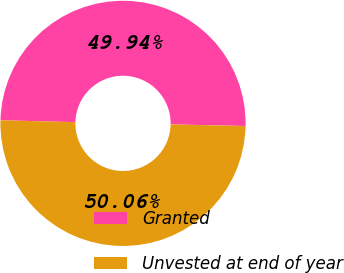<chart> <loc_0><loc_0><loc_500><loc_500><pie_chart><fcel>Granted<fcel>Unvested at end of year<nl><fcel>49.94%<fcel>50.06%<nl></chart> 